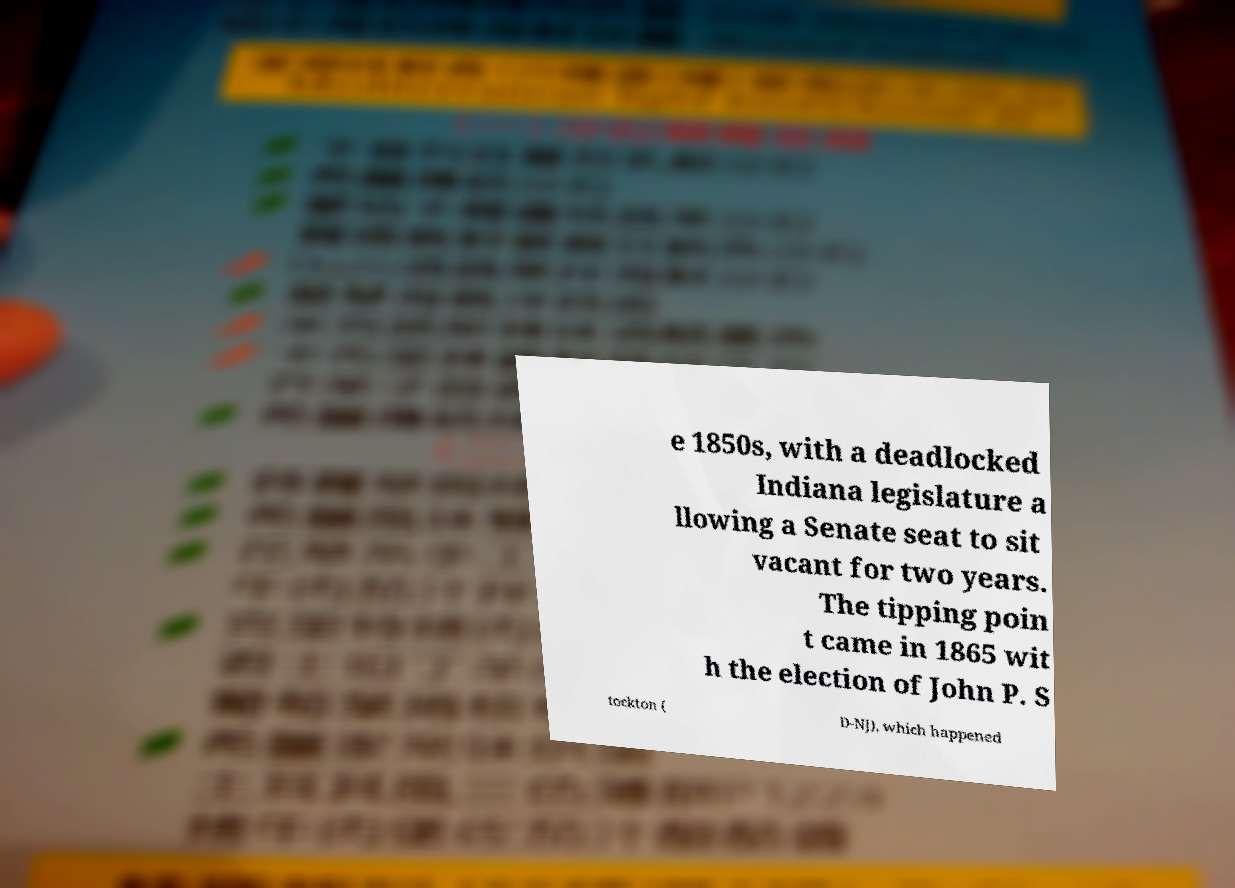I need the written content from this picture converted into text. Can you do that? e 1850s, with a deadlocked Indiana legislature a llowing a Senate seat to sit vacant for two years. The tipping poin t came in 1865 wit h the election of John P. S tockton ( D-NJ), which happened 